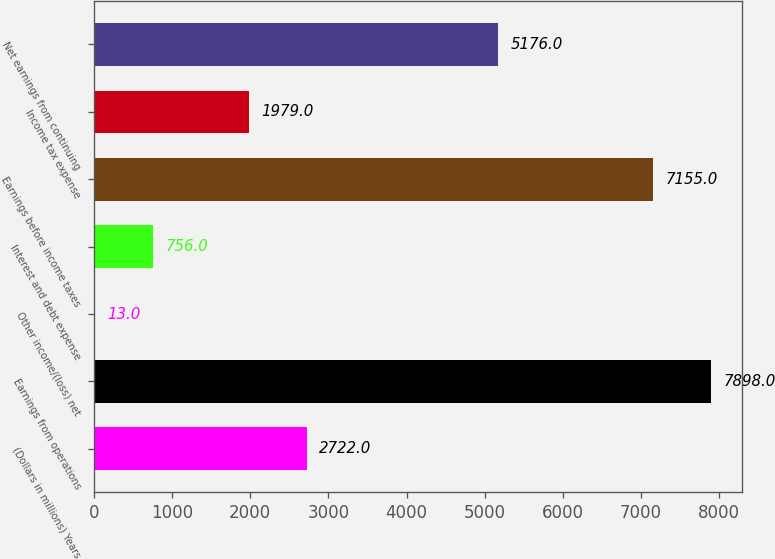<chart> <loc_0><loc_0><loc_500><loc_500><bar_chart><fcel>(Dollars in millions) Years<fcel>Earnings from operations<fcel>Other income/(loss) net<fcel>Interest and debt expense<fcel>Earnings before income taxes<fcel>Income tax expense<fcel>Net earnings from continuing<nl><fcel>2722<fcel>7898<fcel>13<fcel>756<fcel>7155<fcel>1979<fcel>5176<nl></chart> 